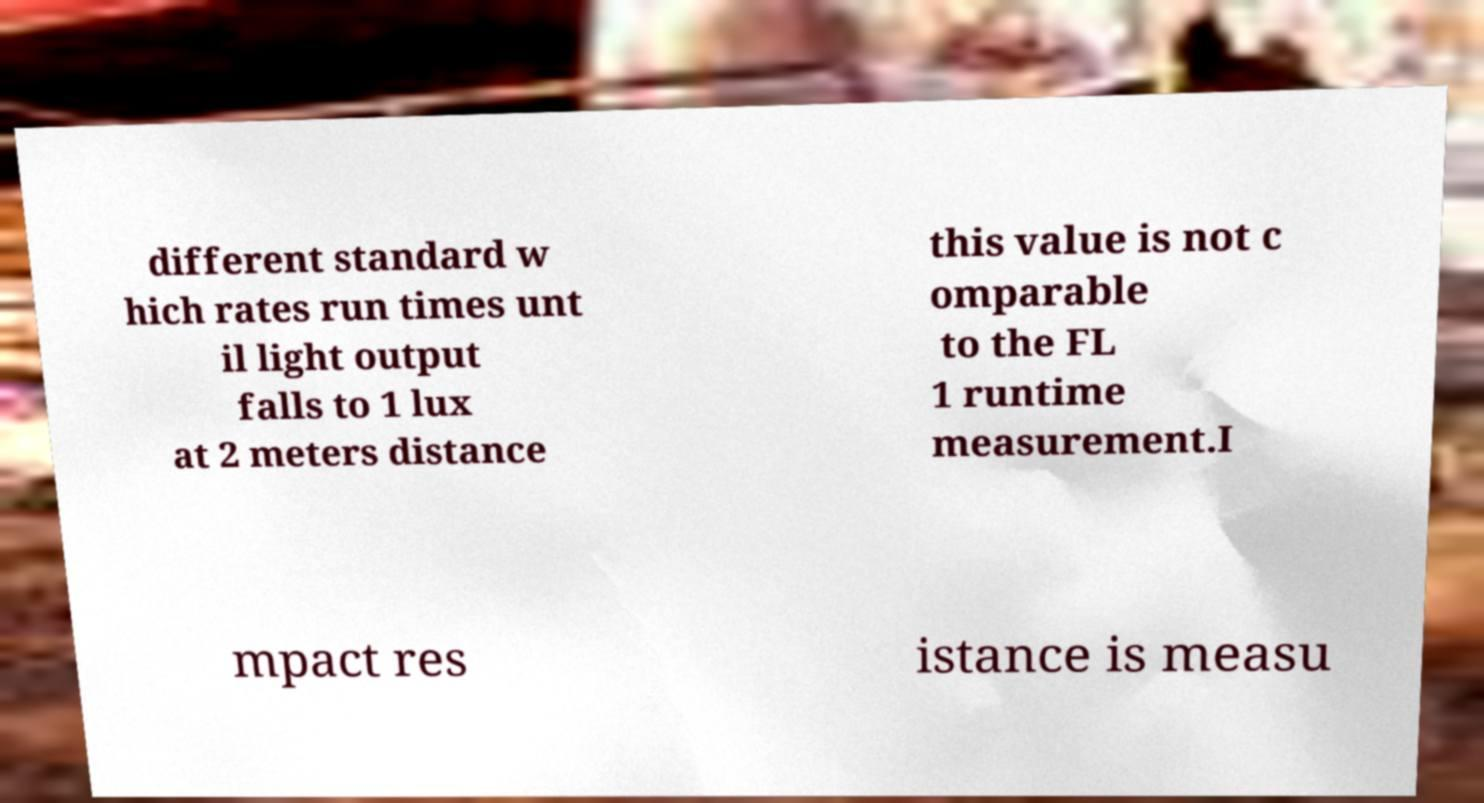There's text embedded in this image that I need extracted. Can you transcribe it verbatim? different standard w hich rates run times unt il light output falls to 1 lux at 2 meters distance this value is not c omparable to the FL 1 runtime measurement.I mpact res istance is measu 